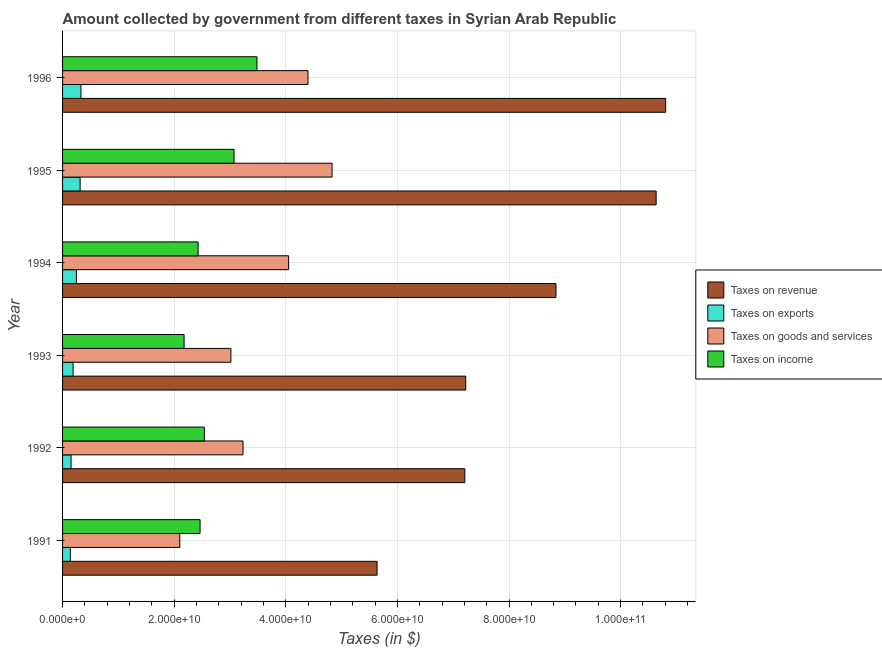Are the number of bars on each tick of the Y-axis equal?
Ensure brevity in your answer.  Yes. How many bars are there on the 4th tick from the top?
Your answer should be compact. 4. How many bars are there on the 5th tick from the bottom?
Keep it short and to the point. 4. What is the label of the 4th group of bars from the top?
Keep it short and to the point. 1993. In how many cases, is the number of bars for a given year not equal to the number of legend labels?
Provide a short and direct response. 0. What is the amount collected as tax on income in 1991?
Give a very brief answer. 2.46e+1. Across all years, what is the maximum amount collected as tax on income?
Your response must be concise. 3.48e+1. Across all years, what is the minimum amount collected as tax on revenue?
Offer a very short reply. 5.64e+1. What is the total amount collected as tax on exports in the graph?
Give a very brief answer. 1.37e+1. What is the difference between the amount collected as tax on goods in 1995 and that in 1996?
Provide a succinct answer. 4.31e+09. What is the difference between the amount collected as tax on revenue in 1994 and the amount collected as tax on exports in 1991?
Ensure brevity in your answer.  8.70e+1. What is the average amount collected as tax on revenue per year?
Your answer should be very brief. 8.39e+1. In the year 1995, what is the difference between the amount collected as tax on revenue and amount collected as tax on goods?
Keep it short and to the point. 5.81e+1. In how many years, is the amount collected as tax on goods greater than 68000000000 $?
Make the answer very short. 0. What is the ratio of the amount collected as tax on income in 1993 to that in 1995?
Offer a terse response. 0.71. Is the amount collected as tax on income in 1992 less than that in 1993?
Ensure brevity in your answer.  No. Is the difference between the amount collected as tax on exports in 1991 and 1993 greater than the difference between the amount collected as tax on revenue in 1991 and 1993?
Your answer should be very brief. Yes. What is the difference between the highest and the second highest amount collected as tax on revenue?
Make the answer very short. 1.70e+09. What is the difference between the highest and the lowest amount collected as tax on goods?
Make the answer very short. 2.73e+1. In how many years, is the amount collected as tax on goods greater than the average amount collected as tax on goods taken over all years?
Provide a short and direct response. 3. Is it the case that in every year, the sum of the amount collected as tax on goods and amount collected as tax on exports is greater than the sum of amount collected as tax on income and amount collected as tax on revenue?
Give a very brief answer. No. What does the 4th bar from the top in 1991 represents?
Your answer should be very brief. Taxes on revenue. What does the 1st bar from the bottom in 1993 represents?
Make the answer very short. Taxes on revenue. How many years are there in the graph?
Keep it short and to the point. 6. Are the values on the major ticks of X-axis written in scientific E-notation?
Your answer should be compact. Yes. Where does the legend appear in the graph?
Offer a very short reply. Center right. How are the legend labels stacked?
Offer a very short reply. Vertical. What is the title of the graph?
Your answer should be very brief. Amount collected by government from different taxes in Syrian Arab Republic. Does "Fiscal policy" appear as one of the legend labels in the graph?
Offer a terse response. No. What is the label or title of the X-axis?
Your answer should be compact. Taxes (in $). What is the label or title of the Y-axis?
Your answer should be very brief. Year. What is the Taxes (in $) of Taxes on revenue in 1991?
Your response must be concise. 5.64e+1. What is the Taxes (in $) in Taxes on exports in 1991?
Offer a very short reply. 1.39e+09. What is the Taxes (in $) of Taxes on goods and services in 1991?
Offer a very short reply. 2.10e+1. What is the Taxes (in $) of Taxes on income in 1991?
Offer a terse response. 2.46e+1. What is the Taxes (in $) of Taxes on revenue in 1992?
Offer a terse response. 7.21e+1. What is the Taxes (in $) in Taxes on exports in 1992?
Your answer should be compact. 1.52e+09. What is the Taxes (in $) of Taxes on goods and services in 1992?
Give a very brief answer. 3.23e+1. What is the Taxes (in $) of Taxes on income in 1992?
Your response must be concise. 2.54e+1. What is the Taxes (in $) in Taxes on revenue in 1993?
Provide a short and direct response. 7.22e+1. What is the Taxes (in $) of Taxes on exports in 1993?
Offer a terse response. 1.88e+09. What is the Taxes (in $) in Taxes on goods and services in 1993?
Ensure brevity in your answer.  3.02e+1. What is the Taxes (in $) in Taxes on income in 1993?
Keep it short and to the point. 2.18e+1. What is the Taxes (in $) of Taxes on revenue in 1994?
Provide a short and direct response. 8.84e+1. What is the Taxes (in $) in Taxes on exports in 1994?
Ensure brevity in your answer.  2.48e+09. What is the Taxes (in $) of Taxes on goods and services in 1994?
Your response must be concise. 4.05e+1. What is the Taxes (in $) of Taxes on income in 1994?
Ensure brevity in your answer.  2.43e+1. What is the Taxes (in $) in Taxes on revenue in 1995?
Give a very brief answer. 1.06e+11. What is the Taxes (in $) of Taxes on exports in 1995?
Provide a succinct answer. 3.15e+09. What is the Taxes (in $) in Taxes on goods and services in 1995?
Provide a short and direct response. 4.83e+1. What is the Taxes (in $) of Taxes on income in 1995?
Make the answer very short. 3.07e+1. What is the Taxes (in $) of Taxes on revenue in 1996?
Keep it short and to the point. 1.08e+11. What is the Taxes (in $) in Taxes on exports in 1996?
Offer a terse response. 3.29e+09. What is the Taxes (in $) of Taxes on goods and services in 1996?
Provide a short and direct response. 4.40e+1. What is the Taxes (in $) in Taxes on income in 1996?
Make the answer very short. 3.48e+1. Across all years, what is the maximum Taxes (in $) in Taxes on revenue?
Ensure brevity in your answer.  1.08e+11. Across all years, what is the maximum Taxes (in $) of Taxes on exports?
Keep it short and to the point. 3.29e+09. Across all years, what is the maximum Taxes (in $) of Taxes on goods and services?
Ensure brevity in your answer.  4.83e+1. Across all years, what is the maximum Taxes (in $) of Taxes on income?
Keep it short and to the point. 3.48e+1. Across all years, what is the minimum Taxes (in $) in Taxes on revenue?
Ensure brevity in your answer.  5.64e+1. Across all years, what is the minimum Taxes (in $) in Taxes on exports?
Your answer should be very brief. 1.39e+09. Across all years, what is the minimum Taxes (in $) in Taxes on goods and services?
Offer a very short reply. 2.10e+1. Across all years, what is the minimum Taxes (in $) in Taxes on income?
Keep it short and to the point. 2.18e+1. What is the total Taxes (in $) of Taxes on revenue in the graph?
Provide a short and direct response. 5.04e+11. What is the total Taxes (in $) of Taxes on exports in the graph?
Give a very brief answer. 1.37e+1. What is the total Taxes (in $) in Taxes on goods and services in the graph?
Make the answer very short. 2.16e+11. What is the total Taxes (in $) of Taxes on income in the graph?
Your answer should be very brief. 1.62e+11. What is the difference between the Taxes (in $) of Taxes on revenue in 1991 and that in 1992?
Offer a very short reply. -1.57e+1. What is the difference between the Taxes (in $) in Taxes on exports in 1991 and that in 1992?
Your response must be concise. -1.31e+08. What is the difference between the Taxes (in $) in Taxes on goods and services in 1991 and that in 1992?
Your response must be concise. -1.13e+1. What is the difference between the Taxes (in $) in Taxes on income in 1991 and that in 1992?
Ensure brevity in your answer.  -7.67e+08. What is the difference between the Taxes (in $) in Taxes on revenue in 1991 and that in 1993?
Keep it short and to the point. -1.59e+1. What is the difference between the Taxes (in $) of Taxes on exports in 1991 and that in 1993?
Offer a terse response. -4.92e+08. What is the difference between the Taxes (in $) of Taxes on goods and services in 1991 and that in 1993?
Provide a short and direct response. -9.16e+09. What is the difference between the Taxes (in $) of Taxes on income in 1991 and that in 1993?
Provide a short and direct response. 2.86e+09. What is the difference between the Taxes (in $) in Taxes on revenue in 1991 and that in 1994?
Provide a succinct answer. -3.21e+1. What is the difference between the Taxes (in $) of Taxes on exports in 1991 and that in 1994?
Ensure brevity in your answer.  -1.08e+09. What is the difference between the Taxes (in $) in Taxes on goods and services in 1991 and that in 1994?
Keep it short and to the point. -1.95e+1. What is the difference between the Taxes (in $) in Taxes on income in 1991 and that in 1994?
Keep it short and to the point. 3.50e+08. What is the difference between the Taxes (in $) in Taxes on revenue in 1991 and that in 1995?
Offer a very short reply. -5.00e+1. What is the difference between the Taxes (in $) in Taxes on exports in 1991 and that in 1995?
Offer a terse response. -1.76e+09. What is the difference between the Taxes (in $) in Taxes on goods and services in 1991 and that in 1995?
Your response must be concise. -2.73e+1. What is the difference between the Taxes (in $) of Taxes on income in 1991 and that in 1995?
Give a very brief answer. -6.08e+09. What is the difference between the Taxes (in $) of Taxes on revenue in 1991 and that in 1996?
Offer a terse response. -5.17e+1. What is the difference between the Taxes (in $) in Taxes on exports in 1991 and that in 1996?
Ensure brevity in your answer.  -1.90e+09. What is the difference between the Taxes (in $) in Taxes on goods and services in 1991 and that in 1996?
Your answer should be very brief. -2.30e+1. What is the difference between the Taxes (in $) of Taxes on income in 1991 and that in 1996?
Your answer should be compact. -1.02e+1. What is the difference between the Taxes (in $) of Taxes on revenue in 1992 and that in 1993?
Your answer should be very brief. -1.62e+08. What is the difference between the Taxes (in $) of Taxes on exports in 1992 and that in 1993?
Your answer should be compact. -3.61e+08. What is the difference between the Taxes (in $) in Taxes on goods and services in 1992 and that in 1993?
Ensure brevity in your answer.  2.17e+09. What is the difference between the Taxes (in $) of Taxes on income in 1992 and that in 1993?
Your response must be concise. 3.63e+09. What is the difference between the Taxes (in $) of Taxes on revenue in 1992 and that in 1994?
Your answer should be compact. -1.63e+1. What is the difference between the Taxes (in $) in Taxes on exports in 1992 and that in 1994?
Your response must be concise. -9.54e+08. What is the difference between the Taxes (in $) of Taxes on goods and services in 1992 and that in 1994?
Keep it short and to the point. -8.17e+09. What is the difference between the Taxes (in $) in Taxes on income in 1992 and that in 1994?
Your answer should be very brief. 1.12e+09. What is the difference between the Taxes (in $) of Taxes on revenue in 1992 and that in 1995?
Provide a short and direct response. -3.43e+1. What is the difference between the Taxes (in $) in Taxes on exports in 1992 and that in 1995?
Provide a short and direct response. -1.63e+09. What is the difference between the Taxes (in $) of Taxes on goods and services in 1992 and that in 1995?
Make the answer very short. -1.60e+1. What is the difference between the Taxes (in $) in Taxes on income in 1992 and that in 1995?
Give a very brief answer. -5.32e+09. What is the difference between the Taxes (in $) of Taxes on revenue in 1992 and that in 1996?
Provide a succinct answer. -3.60e+1. What is the difference between the Taxes (in $) of Taxes on exports in 1992 and that in 1996?
Offer a terse response. -1.77e+09. What is the difference between the Taxes (in $) of Taxes on goods and services in 1992 and that in 1996?
Your answer should be compact. -1.16e+1. What is the difference between the Taxes (in $) in Taxes on income in 1992 and that in 1996?
Provide a succinct answer. -9.43e+09. What is the difference between the Taxes (in $) in Taxes on revenue in 1993 and that in 1994?
Offer a very short reply. -1.62e+1. What is the difference between the Taxes (in $) of Taxes on exports in 1993 and that in 1994?
Ensure brevity in your answer.  -5.93e+08. What is the difference between the Taxes (in $) in Taxes on goods and services in 1993 and that in 1994?
Give a very brief answer. -1.03e+1. What is the difference between the Taxes (in $) of Taxes on income in 1993 and that in 1994?
Ensure brevity in your answer.  -2.52e+09. What is the difference between the Taxes (in $) of Taxes on revenue in 1993 and that in 1995?
Provide a succinct answer. -3.41e+1. What is the difference between the Taxes (in $) of Taxes on exports in 1993 and that in 1995?
Offer a terse response. -1.26e+09. What is the difference between the Taxes (in $) of Taxes on goods and services in 1993 and that in 1995?
Give a very brief answer. -1.81e+1. What is the difference between the Taxes (in $) in Taxes on income in 1993 and that in 1995?
Give a very brief answer. -8.95e+09. What is the difference between the Taxes (in $) of Taxes on revenue in 1993 and that in 1996?
Give a very brief answer. -3.58e+1. What is the difference between the Taxes (in $) in Taxes on exports in 1993 and that in 1996?
Provide a succinct answer. -1.41e+09. What is the difference between the Taxes (in $) of Taxes on goods and services in 1993 and that in 1996?
Your answer should be very brief. -1.38e+1. What is the difference between the Taxes (in $) in Taxes on income in 1993 and that in 1996?
Offer a terse response. -1.31e+1. What is the difference between the Taxes (in $) in Taxes on revenue in 1994 and that in 1995?
Keep it short and to the point. -1.80e+1. What is the difference between the Taxes (in $) in Taxes on exports in 1994 and that in 1995?
Offer a very short reply. -6.72e+08. What is the difference between the Taxes (in $) in Taxes on goods and services in 1994 and that in 1995?
Provide a succinct answer. -7.78e+09. What is the difference between the Taxes (in $) in Taxes on income in 1994 and that in 1995?
Your answer should be very brief. -6.43e+09. What is the difference between the Taxes (in $) in Taxes on revenue in 1994 and that in 1996?
Keep it short and to the point. -1.97e+1. What is the difference between the Taxes (in $) of Taxes on exports in 1994 and that in 1996?
Keep it short and to the point. -8.15e+08. What is the difference between the Taxes (in $) of Taxes on goods and services in 1994 and that in 1996?
Your answer should be compact. -3.47e+09. What is the difference between the Taxes (in $) of Taxes on income in 1994 and that in 1996?
Your answer should be very brief. -1.05e+1. What is the difference between the Taxes (in $) in Taxes on revenue in 1995 and that in 1996?
Offer a very short reply. -1.70e+09. What is the difference between the Taxes (in $) of Taxes on exports in 1995 and that in 1996?
Your response must be concise. -1.43e+08. What is the difference between the Taxes (in $) of Taxes on goods and services in 1995 and that in 1996?
Offer a very short reply. 4.31e+09. What is the difference between the Taxes (in $) of Taxes on income in 1995 and that in 1996?
Offer a terse response. -4.11e+09. What is the difference between the Taxes (in $) in Taxes on revenue in 1991 and the Taxes (in $) in Taxes on exports in 1992?
Provide a succinct answer. 5.48e+1. What is the difference between the Taxes (in $) of Taxes on revenue in 1991 and the Taxes (in $) of Taxes on goods and services in 1992?
Provide a short and direct response. 2.40e+1. What is the difference between the Taxes (in $) of Taxes on revenue in 1991 and the Taxes (in $) of Taxes on income in 1992?
Offer a very short reply. 3.10e+1. What is the difference between the Taxes (in $) of Taxes on exports in 1991 and the Taxes (in $) of Taxes on goods and services in 1992?
Ensure brevity in your answer.  -3.09e+1. What is the difference between the Taxes (in $) of Taxes on exports in 1991 and the Taxes (in $) of Taxes on income in 1992?
Your answer should be very brief. -2.40e+1. What is the difference between the Taxes (in $) of Taxes on goods and services in 1991 and the Taxes (in $) of Taxes on income in 1992?
Offer a very short reply. -4.40e+09. What is the difference between the Taxes (in $) in Taxes on revenue in 1991 and the Taxes (in $) in Taxes on exports in 1993?
Offer a very short reply. 5.45e+1. What is the difference between the Taxes (in $) in Taxes on revenue in 1991 and the Taxes (in $) in Taxes on goods and services in 1993?
Your response must be concise. 2.62e+1. What is the difference between the Taxes (in $) of Taxes on revenue in 1991 and the Taxes (in $) of Taxes on income in 1993?
Ensure brevity in your answer.  3.46e+1. What is the difference between the Taxes (in $) of Taxes on exports in 1991 and the Taxes (in $) of Taxes on goods and services in 1993?
Ensure brevity in your answer.  -2.88e+1. What is the difference between the Taxes (in $) of Taxes on exports in 1991 and the Taxes (in $) of Taxes on income in 1993?
Offer a terse response. -2.04e+1. What is the difference between the Taxes (in $) in Taxes on goods and services in 1991 and the Taxes (in $) in Taxes on income in 1993?
Provide a short and direct response. -7.69e+08. What is the difference between the Taxes (in $) in Taxes on revenue in 1991 and the Taxes (in $) in Taxes on exports in 1994?
Offer a very short reply. 5.39e+1. What is the difference between the Taxes (in $) of Taxes on revenue in 1991 and the Taxes (in $) of Taxes on goods and services in 1994?
Provide a short and direct response. 1.59e+1. What is the difference between the Taxes (in $) of Taxes on revenue in 1991 and the Taxes (in $) of Taxes on income in 1994?
Make the answer very short. 3.21e+1. What is the difference between the Taxes (in $) in Taxes on exports in 1991 and the Taxes (in $) in Taxes on goods and services in 1994?
Your answer should be compact. -3.91e+1. What is the difference between the Taxes (in $) of Taxes on exports in 1991 and the Taxes (in $) of Taxes on income in 1994?
Your response must be concise. -2.29e+1. What is the difference between the Taxes (in $) in Taxes on goods and services in 1991 and the Taxes (in $) in Taxes on income in 1994?
Ensure brevity in your answer.  -3.28e+09. What is the difference between the Taxes (in $) in Taxes on revenue in 1991 and the Taxes (in $) in Taxes on exports in 1995?
Offer a very short reply. 5.32e+1. What is the difference between the Taxes (in $) in Taxes on revenue in 1991 and the Taxes (in $) in Taxes on goods and services in 1995?
Offer a terse response. 8.07e+09. What is the difference between the Taxes (in $) in Taxes on revenue in 1991 and the Taxes (in $) in Taxes on income in 1995?
Offer a very short reply. 2.56e+1. What is the difference between the Taxes (in $) in Taxes on exports in 1991 and the Taxes (in $) in Taxes on goods and services in 1995?
Offer a very short reply. -4.69e+1. What is the difference between the Taxes (in $) in Taxes on exports in 1991 and the Taxes (in $) in Taxes on income in 1995?
Keep it short and to the point. -2.93e+1. What is the difference between the Taxes (in $) of Taxes on goods and services in 1991 and the Taxes (in $) of Taxes on income in 1995?
Provide a succinct answer. -9.72e+09. What is the difference between the Taxes (in $) of Taxes on revenue in 1991 and the Taxes (in $) of Taxes on exports in 1996?
Provide a short and direct response. 5.31e+1. What is the difference between the Taxes (in $) of Taxes on revenue in 1991 and the Taxes (in $) of Taxes on goods and services in 1996?
Your response must be concise. 1.24e+1. What is the difference between the Taxes (in $) in Taxes on revenue in 1991 and the Taxes (in $) in Taxes on income in 1996?
Your response must be concise. 2.15e+1. What is the difference between the Taxes (in $) in Taxes on exports in 1991 and the Taxes (in $) in Taxes on goods and services in 1996?
Offer a very short reply. -4.26e+1. What is the difference between the Taxes (in $) of Taxes on exports in 1991 and the Taxes (in $) of Taxes on income in 1996?
Keep it short and to the point. -3.34e+1. What is the difference between the Taxes (in $) of Taxes on goods and services in 1991 and the Taxes (in $) of Taxes on income in 1996?
Your answer should be very brief. -1.38e+1. What is the difference between the Taxes (in $) in Taxes on revenue in 1992 and the Taxes (in $) in Taxes on exports in 1993?
Your response must be concise. 7.02e+1. What is the difference between the Taxes (in $) of Taxes on revenue in 1992 and the Taxes (in $) of Taxes on goods and services in 1993?
Offer a very short reply. 4.19e+1. What is the difference between the Taxes (in $) in Taxes on revenue in 1992 and the Taxes (in $) in Taxes on income in 1993?
Your response must be concise. 5.03e+1. What is the difference between the Taxes (in $) of Taxes on exports in 1992 and the Taxes (in $) of Taxes on goods and services in 1993?
Offer a terse response. -2.86e+1. What is the difference between the Taxes (in $) in Taxes on exports in 1992 and the Taxes (in $) in Taxes on income in 1993?
Your response must be concise. -2.03e+1. What is the difference between the Taxes (in $) of Taxes on goods and services in 1992 and the Taxes (in $) of Taxes on income in 1993?
Ensure brevity in your answer.  1.06e+1. What is the difference between the Taxes (in $) in Taxes on revenue in 1992 and the Taxes (in $) in Taxes on exports in 1994?
Your response must be concise. 6.96e+1. What is the difference between the Taxes (in $) of Taxes on revenue in 1992 and the Taxes (in $) of Taxes on goods and services in 1994?
Your response must be concise. 3.16e+1. What is the difference between the Taxes (in $) of Taxes on revenue in 1992 and the Taxes (in $) of Taxes on income in 1994?
Offer a very short reply. 4.78e+1. What is the difference between the Taxes (in $) of Taxes on exports in 1992 and the Taxes (in $) of Taxes on goods and services in 1994?
Provide a short and direct response. -3.90e+1. What is the difference between the Taxes (in $) in Taxes on exports in 1992 and the Taxes (in $) in Taxes on income in 1994?
Your response must be concise. -2.28e+1. What is the difference between the Taxes (in $) of Taxes on goods and services in 1992 and the Taxes (in $) of Taxes on income in 1994?
Your answer should be very brief. 8.05e+09. What is the difference between the Taxes (in $) in Taxes on revenue in 1992 and the Taxes (in $) in Taxes on exports in 1995?
Give a very brief answer. 6.89e+1. What is the difference between the Taxes (in $) of Taxes on revenue in 1992 and the Taxes (in $) of Taxes on goods and services in 1995?
Ensure brevity in your answer.  2.38e+1. What is the difference between the Taxes (in $) of Taxes on revenue in 1992 and the Taxes (in $) of Taxes on income in 1995?
Provide a short and direct response. 4.14e+1. What is the difference between the Taxes (in $) of Taxes on exports in 1992 and the Taxes (in $) of Taxes on goods and services in 1995?
Your answer should be very brief. -4.68e+1. What is the difference between the Taxes (in $) in Taxes on exports in 1992 and the Taxes (in $) in Taxes on income in 1995?
Give a very brief answer. -2.92e+1. What is the difference between the Taxes (in $) in Taxes on goods and services in 1992 and the Taxes (in $) in Taxes on income in 1995?
Ensure brevity in your answer.  1.61e+09. What is the difference between the Taxes (in $) of Taxes on revenue in 1992 and the Taxes (in $) of Taxes on exports in 1996?
Offer a very short reply. 6.88e+1. What is the difference between the Taxes (in $) in Taxes on revenue in 1992 and the Taxes (in $) in Taxes on goods and services in 1996?
Ensure brevity in your answer.  2.81e+1. What is the difference between the Taxes (in $) in Taxes on revenue in 1992 and the Taxes (in $) in Taxes on income in 1996?
Give a very brief answer. 3.72e+1. What is the difference between the Taxes (in $) of Taxes on exports in 1992 and the Taxes (in $) of Taxes on goods and services in 1996?
Offer a terse response. -4.25e+1. What is the difference between the Taxes (in $) in Taxes on exports in 1992 and the Taxes (in $) in Taxes on income in 1996?
Keep it short and to the point. -3.33e+1. What is the difference between the Taxes (in $) in Taxes on goods and services in 1992 and the Taxes (in $) in Taxes on income in 1996?
Provide a short and direct response. -2.50e+09. What is the difference between the Taxes (in $) of Taxes on revenue in 1993 and the Taxes (in $) of Taxes on exports in 1994?
Give a very brief answer. 6.98e+1. What is the difference between the Taxes (in $) in Taxes on revenue in 1993 and the Taxes (in $) in Taxes on goods and services in 1994?
Provide a short and direct response. 3.17e+1. What is the difference between the Taxes (in $) in Taxes on revenue in 1993 and the Taxes (in $) in Taxes on income in 1994?
Make the answer very short. 4.80e+1. What is the difference between the Taxes (in $) in Taxes on exports in 1993 and the Taxes (in $) in Taxes on goods and services in 1994?
Ensure brevity in your answer.  -3.86e+1. What is the difference between the Taxes (in $) of Taxes on exports in 1993 and the Taxes (in $) of Taxes on income in 1994?
Keep it short and to the point. -2.24e+1. What is the difference between the Taxes (in $) in Taxes on goods and services in 1993 and the Taxes (in $) in Taxes on income in 1994?
Give a very brief answer. 5.88e+09. What is the difference between the Taxes (in $) of Taxes on revenue in 1993 and the Taxes (in $) of Taxes on exports in 1995?
Your answer should be very brief. 6.91e+1. What is the difference between the Taxes (in $) in Taxes on revenue in 1993 and the Taxes (in $) in Taxes on goods and services in 1995?
Offer a terse response. 2.40e+1. What is the difference between the Taxes (in $) of Taxes on revenue in 1993 and the Taxes (in $) of Taxes on income in 1995?
Provide a succinct answer. 4.15e+1. What is the difference between the Taxes (in $) in Taxes on exports in 1993 and the Taxes (in $) in Taxes on goods and services in 1995?
Your answer should be compact. -4.64e+1. What is the difference between the Taxes (in $) in Taxes on exports in 1993 and the Taxes (in $) in Taxes on income in 1995?
Ensure brevity in your answer.  -2.88e+1. What is the difference between the Taxes (in $) in Taxes on goods and services in 1993 and the Taxes (in $) in Taxes on income in 1995?
Ensure brevity in your answer.  -5.59e+08. What is the difference between the Taxes (in $) of Taxes on revenue in 1993 and the Taxes (in $) of Taxes on exports in 1996?
Your response must be concise. 6.90e+1. What is the difference between the Taxes (in $) of Taxes on revenue in 1993 and the Taxes (in $) of Taxes on goods and services in 1996?
Your answer should be very brief. 2.83e+1. What is the difference between the Taxes (in $) of Taxes on revenue in 1993 and the Taxes (in $) of Taxes on income in 1996?
Your response must be concise. 3.74e+1. What is the difference between the Taxes (in $) of Taxes on exports in 1993 and the Taxes (in $) of Taxes on goods and services in 1996?
Your response must be concise. -4.21e+1. What is the difference between the Taxes (in $) of Taxes on exports in 1993 and the Taxes (in $) of Taxes on income in 1996?
Your answer should be very brief. -3.30e+1. What is the difference between the Taxes (in $) in Taxes on goods and services in 1993 and the Taxes (in $) in Taxes on income in 1996?
Make the answer very short. -4.67e+09. What is the difference between the Taxes (in $) in Taxes on revenue in 1994 and the Taxes (in $) in Taxes on exports in 1995?
Ensure brevity in your answer.  8.53e+1. What is the difference between the Taxes (in $) in Taxes on revenue in 1994 and the Taxes (in $) in Taxes on goods and services in 1995?
Give a very brief answer. 4.01e+1. What is the difference between the Taxes (in $) in Taxes on revenue in 1994 and the Taxes (in $) in Taxes on income in 1995?
Provide a succinct answer. 5.77e+1. What is the difference between the Taxes (in $) of Taxes on exports in 1994 and the Taxes (in $) of Taxes on goods and services in 1995?
Your response must be concise. -4.58e+1. What is the difference between the Taxes (in $) of Taxes on exports in 1994 and the Taxes (in $) of Taxes on income in 1995?
Provide a short and direct response. -2.82e+1. What is the difference between the Taxes (in $) in Taxes on goods and services in 1994 and the Taxes (in $) in Taxes on income in 1995?
Provide a short and direct response. 9.78e+09. What is the difference between the Taxes (in $) in Taxes on revenue in 1994 and the Taxes (in $) in Taxes on exports in 1996?
Your answer should be compact. 8.51e+1. What is the difference between the Taxes (in $) of Taxes on revenue in 1994 and the Taxes (in $) of Taxes on goods and services in 1996?
Your answer should be compact. 4.44e+1. What is the difference between the Taxes (in $) in Taxes on revenue in 1994 and the Taxes (in $) in Taxes on income in 1996?
Make the answer very short. 5.36e+1. What is the difference between the Taxes (in $) in Taxes on exports in 1994 and the Taxes (in $) in Taxes on goods and services in 1996?
Your response must be concise. -4.15e+1. What is the difference between the Taxes (in $) in Taxes on exports in 1994 and the Taxes (in $) in Taxes on income in 1996?
Give a very brief answer. -3.24e+1. What is the difference between the Taxes (in $) of Taxes on goods and services in 1994 and the Taxes (in $) of Taxes on income in 1996?
Provide a succinct answer. 5.67e+09. What is the difference between the Taxes (in $) in Taxes on revenue in 1995 and the Taxes (in $) in Taxes on exports in 1996?
Give a very brief answer. 1.03e+11. What is the difference between the Taxes (in $) of Taxes on revenue in 1995 and the Taxes (in $) of Taxes on goods and services in 1996?
Your answer should be compact. 6.24e+1. What is the difference between the Taxes (in $) in Taxes on revenue in 1995 and the Taxes (in $) in Taxes on income in 1996?
Ensure brevity in your answer.  7.15e+1. What is the difference between the Taxes (in $) in Taxes on exports in 1995 and the Taxes (in $) in Taxes on goods and services in 1996?
Keep it short and to the point. -4.08e+1. What is the difference between the Taxes (in $) of Taxes on exports in 1995 and the Taxes (in $) of Taxes on income in 1996?
Offer a terse response. -3.17e+1. What is the difference between the Taxes (in $) of Taxes on goods and services in 1995 and the Taxes (in $) of Taxes on income in 1996?
Your response must be concise. 1.35e+1. What is the average Taxes (in $) in Taxes on revenue per year?
Give a very brief answer. 8.39e+1. What is the average Taxes (in $) of Taxes on exports per year?
Offer a very short reply. 2.29e+09. What is the average Taxes (in $) in Taxes on goods and services per year?
Your answer should be compact. 3.60e+1. What is the average Taxes (in $) in Taxes on income per year?
Your answer should be compact. 2.69e+1. In the year 1991, what is the difference between the Taxes (in $) of Taxes on revenue and Taxes (in $) of Taxes on exports?
Keep it short and to the point. 5.50e+1. In the year 1991, what is the difference between the Taxes (in $) of Taxes on revenue and Taxes (in $) of Taxes on goods and services?
Make the answer very short. 3.54e+1. In the year 1991, what is the difference between the Taxes (in $) in Taxes on revenue and Taxes (in $) in Taxes on income?
Keep it short and to the point. 3.17e+1. In the year 1991, what is the difference between the Taxes (in $) in Taxes on exports and Taxes (in $) in Taxes on goods and services?
Ensure brevity in your answer.  -1.96e+1. In the year 1991, what is the difference between the Taxes (in $) in Taxes on exports and Taxes (in $) in Taxes on income?
Offer a terse response. -2.32e+1. In the year 1991, what is the difference between the Taxes (in $) in Taxes on goods and services and Taxes (in $) in Taxes on income?
Keep it short and to the point. -3.63e+09. In the year 1992, what is the difference between the Taxes (in $) of Taxes on revenue and Taxes (in $) of Taxes on exports?
Your answer should be compact. 7.06e+1. In the year 1992, what is the difference between the Taxes (in $) of Taxes on revenue and Taxes (in $) of Taxes on goods and services?
Provide a short and direct response. 3.97e+1. In the year 1992, what is the difference between the Taxes (in $) in Taxes on revenue and Taxes (in $) in Taxes on income?
Give a very brief answer. 4.67e+1. In the year 1992, what is the difference between the Taxes (in $) of Taxes on exports and Taxes (in $) of Taxes on goods and services?
Your answer should be very brief. -3.08e+1. In the year 1992, what is the difference between the Taxes (in $) of Taxes on exports and Taxes (in $) of Taxes on income?
Provide a succinct answer. -2.39e+1. In the year 1992, what is the difference between the Taxes (in $) in Taxes on goods and services and Taxes (in $) in Taxes on income?
Provide a short and direct response. 6.93e+09. In the year 1993, what is the difference between the Taxes (in $) in Taxes on revenue and Taxes (in $) in Taxes on exports?
Your response must be concise. 7.04e+1. In the year 1993, what is the difference between the Taxes (in $) in Taxes on revenue and Taxes (in $) in Taxes on goods and services?
Make the answer very short. 4.21e+1. In the year 1993, what is the difference between the Taxes (in $) of Taxes on revenue and Taxes (in $) of Taxes on income?
Your answer should be compact. 5.05e+1. In the year 1993, what is the difference between the Taxes (in $) in Taxes on exports and Taxes (in $) in Taxes on goods and services?
Keep it short and to the point. -2.83e+1. In the year 1993, what is the difference between the Taxes (in $) of Taxes on exports and Taxes (in $) of Taxes on income?
Provide a succinct answer. -1.99e+1. In the year 1993, what is the difference between the Taxes (in $) in Taxes on goods and services and Taxes (in $) in Taxes on income?
Your response must be concise. 8.39e+09. In the year 1994, what is the difference between the Taxes (in $) in Taxes on revenue and Taxes (in $) in Taxes on exports?
Keep it short and to the point. 8.59e+1. In the year 1994, what is the difference between the Taxes (in $) of Taxes on revenue and Taxes (in $) of Taxes on goods and services?
Offer a terse response. 4.79e+1. In the year 1994, what is the difference between the Taxes (in $) in Taxes on revenue and Taxes (in $) in Taxes on income?
Offer a very short reply. 6.41e+1. In the year 1994, what is the difference between the Taxes (in $) of Taxes on exports and Taxes (in $) of Taxes on goods and services?
Your answer should be very brief. -3.80e+1. In the year 1994, what is the difference between the Taxes (in $) in Taxes on exports and Taxes (in $) in Taxes on income?
Your answer should be very brief. -2.18e+1. In the year 1994, what is the difference between the Taxes (in $) of Taxes on goods and services and Taxes (in $) of Taxes on income?
Your answer should be compact. 1.62e+1. In the year 1995, what is the difference between the Taxes (in $) in Taxes on revenue and Taxes (in $) in Taxes on exports?
Ensure brevity in your answer.  1.03e+11. In the year 1995, what is the difference between the Taxes (in $) in Taxes on revenue and Taxes (in $) in Taxes on goods and services?
Your answer should be very brief. 5.81e+1. In the year 1995, what is the difference between the Taxes (in $) of Taxes on revenue and Taxes (in $) of Taxes on income?
Give a very brief answer. 7.56e+1. In the year 1995, what is the difference between the Taxes (in $) in Taxes on exports and Taxes (in $) in Taxes on goods and services?
Offer a terse response. -4.51e+1. In the year 1995, what is the difference between the Taxes (in $) of Taxes on exports and Taxes (in $) of Taxes on income?
Ensure brevity in your answer.  -2.76e+1. In the year 1995, what is the difference between the Taxes (in $) of Taxes on goods and services and Taxes (in $) of Taxes on income?
Your answer should be compact. 1.76e+1. In the year 1996, what is the difference between the Taxes (in $) in Taxes on revenue and Taxes (in $) in Taxes on exports?
Ensure brevity in your answer.  1.05e+11. In the year 1996, what is the difference between the Taxes (in $) of Taxes on revenue and Taxes (in $) of Taxes on goods and services?
Keep it short and to the point. 6.41e+1. In the year 1996, what is the difference between the Taxes (in $) in Taxes on revenue and Taxes (in $) in Taxes on income?
Your response must be concise. 7.32e+1. In the year 1996, what is the difference between the Taxes (in $) of Taxes on exports and Taxes (in $) of Taxes on goods and services?
Give a very brief answer. -4.07e+1. In the year 1996, what is the difference between the Taxes (in $) of Taxes on exports and Taxes (in $) of Taxes on income?
Your answer should be very brief. -3.15e+1. In the year 1996, what is the difference between the Taxes (in $) of Taxes on goods and services and Taxes (in $) of Taxes on income?
Offer a terse response. 9.14e+09. What is the ratio of the Taxes (in $) of Taxes on revenue in 1991 to that in 1992?
Give a very brief answer. 0.78. What is the ratio of the Taxes (in $) in Taxes on exports in 1991 to that in 1992?
Keep it short and to the point. 0.91. What is the ratio of the Taxes (in $) of Taxes on goods and services in 1991 to that in 1992?
Offer a terse response. 0.65. What is the ratio of the Taxes (in $) of Taxes on income in 1991 to that in 1992?
Provide a short and direct response. 0.97. What is the ratio of the Taxes (in $) in Taxes on revenue in 1991 to that in 1993?
Give a very brief answer. 0.78. What is the ratio of the Taxes (in $) in Taxes on exports in 1991 to that in 1993?
Ensure brevity in your answer.  0.74. What is the ratio of the Taxes (in $) in Taxes on goods and services in 1991 to that in 1993?
Give a very brief answer. 0.7. What is the ratio of the Taxes (in $) of Taxes on income in 1991 to that in 1993?
Ensure brevity in your answer.  1.13. What is the ratio of the Taxes (in $) of Taxes on revenue in 1991 to that in 1994?
Give a very brief answer. 0.64. What is the ratio of the Taxes (in $) in Taxes on exports in 1991 to that in 1994?
Make the answer very short. 0.56. What is the ratio of the Taxes (in $) of Taxes on goods and services in 1991 to that in 1994?
Keep it short and to the point. 0.52. What is the ratio of the Taxes (in $) of Taxes on income in 1991 to that in 1994?
Your answer should be very brief. 1.01. What is the ratio of the Taxes (in $) of Taxes on revenue in 1991 to that in 1995?
Provide a succinct answer. 0.53. What is the ratio of the Taxes (in $) in Taxes on exports in 1991 to that in 1995?
Make the answer very short. 0.44. What is the ratio of the Taxes (in $) of Taxes on goods and services in 1991 to that in 1995?
Make the answer very short. 0.43. What is the ratio of the Taxes (in $) of Taxes on income in 1991 to that in 1995?
Offer a very short reply. 0.8. What is the ratio of the Taxes (in $) of Taxes on revenue in 1991 to that in 1996?
Ensure brevity in your answer.  0.52. What is the ratio of the Taxes (in $) of Taxes on exports in 1991 to that in 1996?
Make the answer very short. 0.42. What is the ratio of the Taxes (in $) in Taxes on goods and services in 1991 to that in 1996?
Provide a succinct answer. 0.48. What is the ratio of the Taxes (in $) of Taxes on income in 1991 to that in 1996?
Provide a succinct answer. 0.71. What is the ratio of the Taxes (in $) in Taxes on revenue in 1992 to that in 1993?
Provide a short and direct response. 1. What is the ratio of the Taxes (in $) in Taxes on exports in 1992 to that in 1993?
Make the answer very short. 0.81. What is the ratio of the Taxes (in $) in Taxes on goods and services in 1992 to that in 1993?
Offer a terse response. 1.07. What is the ratio of the Taxes (in $) in Taxes on income in 1992 to that in 1993?
Offer a very short reply. 1.17. What is the ratio of the Taxes (in $) of Taxes on revenue in 1992 to that in 1994?
Your answer should be compact. 0.82. What is the ratio of the Taxes (in $) in Taxes on exports in 1992 to that in 1994?
Your answer should be very brief. 0.61. What is the ratio of the Taxes (in $) in Taxes on goods and services in 1992 to that in 1994?
Ensure brevity in your answer.  0.8. What is the ratio of the Taxes (in $) of Taxes on income in 1992 to that in 1994?
Offer a very short reply. 1.05. What is the ratio of the Taxes (in $) of Taxes on revenue in 1992 to that in 1995?
Make the answer very short. 0.68. What is the ratio of the Taxes (in $) of Taxes on exports in 1992 to that in 1995?
Your answer should be compact. 0.48. What is the ratio of the Taxes (in $) of Taxes on goods and services in 1992 to that in 1995?
Your response must be concise. 0.67. What is the ratio of the Taxes (in $) of Taxes on income in 1992 to that in 1995?
Provide a short and direct response. 0.83. What is the ratio of the Taxes (in $) in Taxes on revenue in 1992 to that in 1996?
Make the answer very short. 0.67. What is the ratio of the Taxes (in $) in Taxes on exports in 1992 to that in 1996?
Your response must be concise. 0.46. What is the ratio of the Taxes (in $) in Taxes on goods and services in 1992 to that in 1996?
Make the answer very short. 0.74. What is the ratio of the Taxes (in $) of Taxes on income in 1992 to that in 1996?
Offer a very short reply. 0.73. What is the ratio of the Taxes (in $) in Taxes on revenue in 1993 to that in 1994?
Offer a very short reply. 0.82. What is the ratio of the Taxes (in $) of Taxes on exports in 1993 to that in 1994?
Your response must be concise. 0.76. What is the ratio of the Taxes (in $) of Taxes on goods and services in 1993 to that in 1994?
Keep it short and to the point. 0.74. What is the ratio of the Taxes (in $) in Taxes on income in 1993 to that in 1994?
Offer a terse response. 0.9. What is the ratio of the Taxes (in $) in Taxes on revenue in 1993 to that in 1995?
Offer a terse response. 0.68. What is the ratio of the Taxes (in $) of Taxes on exports in 1993 to that in 1995?
Make the answer very short. 0.6. What is the ratio of the Taxes (in $) of Taxes on goods and services in 1993 to that in 1995?
Your response must be concise. 0.62. What is the ratio of the Taxes (in $) in Taxes on income in 1993 to that in 1995?
Offer a very short reply. 0.71. What is the ratio of the Taxes (in $) of Taxes on revenue in 1993 to that in 1996?
Keep it short and to the point. 0.67. What is the ratio of the Taxes (in $) in Taxes on exports in 1993 to that in 1996?
Ensure brevity in your answer.  0.57. What is the ratio of the Taxes (in $) in Taxes on goods and services in 1993 to that in 1996?
Provide a succinct answer. 0.69. What is the ratio of the Taxes (in $) in Taxes on income in 1993 to that in 1996?
Your answer should be compact. 0.63. What is the ratio of the Taxes (in $) of Taxes on revenue in 1994 to that in 1995?
Offer a very short reply. 0.83. What is the ratio of the Taxes (in $) in Taxes on exports in 1994 to that in 1995?
Provide a short and direct response. 0.79. What is the ratio of the Taxes (in $) of Taxes on goods and services in 1994 to that in 1995?
Keep it short and to the point. 0.84. What is the ratio of the Taxes (in $) in Taxes on income in 1994 to that in 1995?
Your answer should be compact. 0.79. What is the ratio of the Taxes (in $) in Taxes on revenue in 1994 to that in 1996?
Offer a very short reply. 0.82. What is the ratio of the Taxes (in $) in Taxes on exports in 1994 to that in 1996?
Your response must be concise. 0.75. What is the ratio of the Taxes (in $) in Taxes on goods and services in 1994 to that in 1996?
Make the answer very short. 0.92. What is the ratio of the Taxes (in $) in Taxes on income in 1994 to that in 1996?
Offer a very short reply. 0.7. What is the ratio of the Taxes (in $) in Taxes on revenue in 1995 to that in 1996?
Offer a very short reply. 0.98. What is the ratio of the Taxes (in $) in Taxes on exports in 1995 to that in 1996?
Your answer should be very brief. 0.96. What is the ratio of the Taxes (in $) in Taxes on goods and services in 1995 to that in 1996?
Provide a short and direct response. 1.1. What is the ratio of the Taxes (in $) of Taxes on income in 1995 to that in 1996?
Keep it short and to the point. 0.88. What is the difference between the highest and the second highest Taxes (in $) of Taxes on revenue?
Keep it short and to the point. 1.70e+09. What is the difference between the highest and the second highest Taxes (in $) in Taxes on exports?
Keep it short and to the point. 1.43e+08. What is the difference between the highest and the second highest Taxes (in $) in Taxes on goods and services?
Your answer should be compact. 4.31e+09. What is the difference between the highest and the second highest Taxes (in $) in Taxes on income?
Provide a short and direct response. 4.11e+09. What is the difference between the highest and the lowest Taxes (in $) of Taxes on revenue?
Offer a very short reply. 5.17e+1. What is the difference between the highest and the lowest Taxes (in $) in Taxes on exports?
Make the answer very short. 1.90e+09. What is the difference between the highest and the lowest Taxes (in $) in Taxes on goods and services?
Ensure brevity in your answer.  2.73e+1. What is the difference between the highest and the lowest Taxes (in $) of Taxes on income?
Your answer should be very brief. 1.31e+1. 